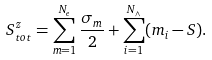Convert formula to latex. <formula><loc_0><loc_0><loc_500><loc_500>S _ { t o t } ^ { z } = \sum _ { m = 1 } ^ { N _ { e } } \frac { \sigma _ { m } } { 2 } + \sum _ { i = 1 } ^ { N _ { \wedge } } ( m _ { i } - S ) .</formula> 